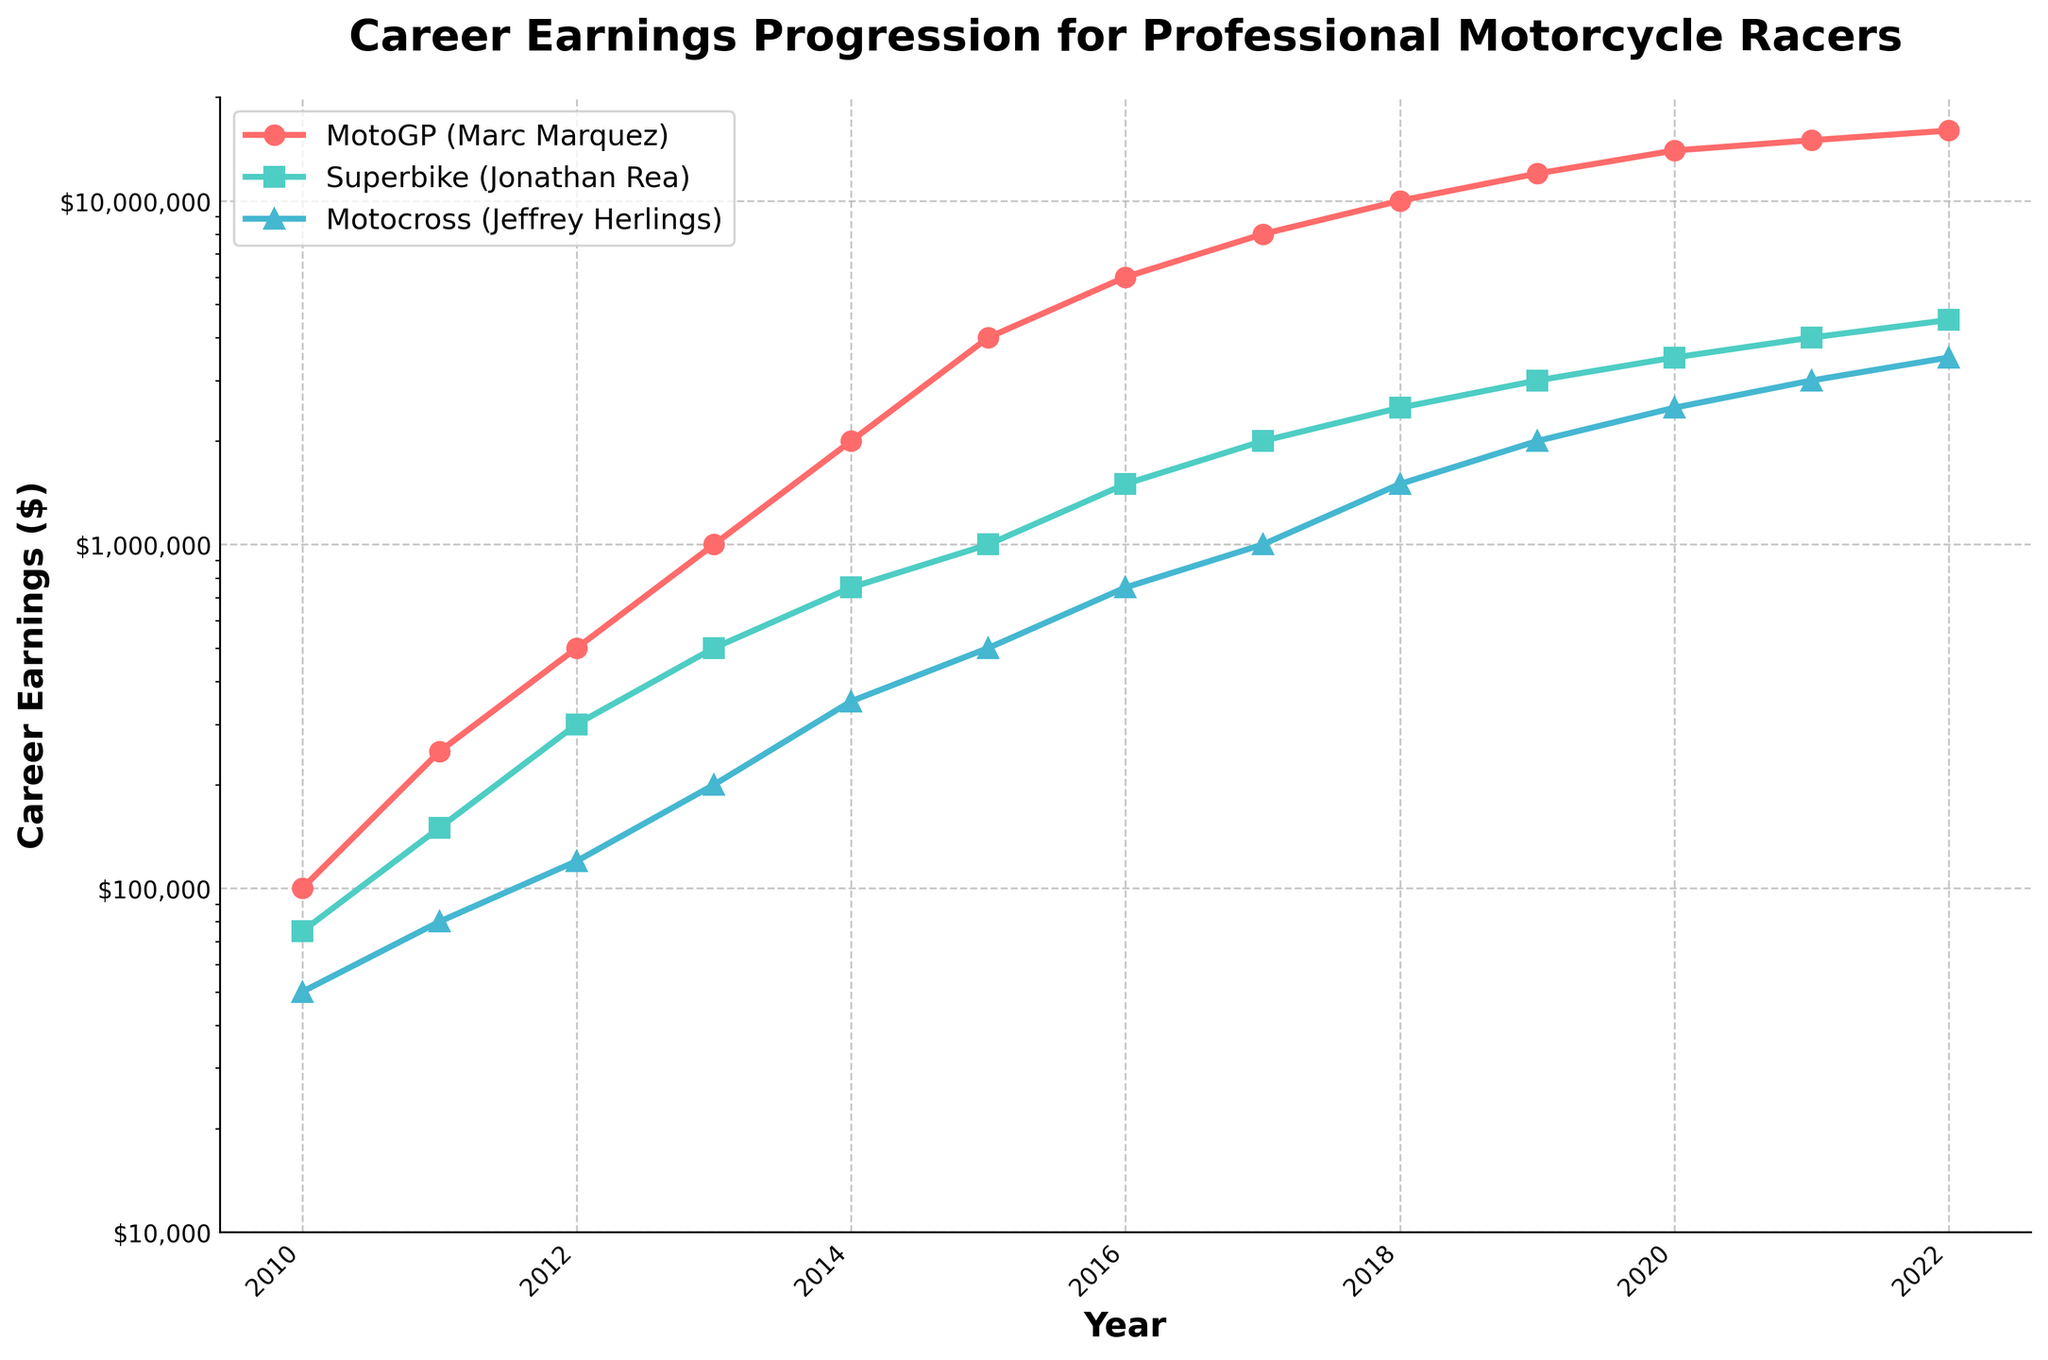How many more earnings did Marc Marquez have in 2022 compared to Jonathan Rea? To determine how much more Marc Marquez earned compared to Jonathan Rea in 2022, subtract Jonathan Rea's earnings from Marc Marquez's earnings: $16,000,000 (Marquez) - $4,500,000 (Rea) = $11,500,000
Answer: $11,500,000 Which rider had the steepest increase in earnings between 2015 and 2016? Examine the increase in earnings for each rider between 2015 and 2016: Marc Marquez's earnings increased from $4,000,000 to $6,000,000 ($2,000,000 increase); Jonathan Rea's earnings increased from $1,000,000 to $1,500,000 ($500,000 increase); Jeffrey Herlings' earnings increased from $500,000 to $750,000 ($250,000 increase). The steepest increase is for Marc Marquez.
Answer: Marc Marquez Was there a year when the earnings for all three riders were below $1,000,000? Review the earnings data year by year to check if all three riders' earnings are below $1,000,000. In 2010, Marc Marquez earned $100,000, Jonathan Rea earned $75,000, and Jeffrey Herlings earned $50,000, all of which are below $1,000,000.
Answer: 2010 In which year did Jeffrey Herlings' earnings first exceed $1,000,000? Examine the yearly earnings for Jeffrey Herlings until finding the first instance when the amount exceeds $1,000,000. This occurs in 2017 when his earnings are $1,000,000 exactly, and in 2018 they reach $1,500,000. So, 2018 is the year his earnings first exceed $1,000,000.
Answer: 2018 How long did it take for Jonathan Rea's earnings to increase from $750,000 to $4,000,000? Identify the years when Jonathan Rea's earnings were $750,000 and $4,000,000. His earnings were $750,000 in 2014 and $4,000,000 in 2021, so it took 2021 - 2014 = 7 years.
Answer: 7 years Which rider had the highest earnings in 2013, and what were they? Compare the earnings of the three riders in 2013: Marc Marquez ($1,000,000), Jonathan Rea ($500,000), Jeffrey Herlings ($200,000). The highest earnings in 2013 were by Marc Marquez with $1,000,000.
Answer: Marc Marquez, $1,000,000 What is the total earnings difference between MotoGP and Superbike from 2010 to 2022? Sum the earnings for Marc Marquez (MotoGP) and Jonathan Rea (Superbike) from 2010 to 2022, then calculate the difference. Total earnings for Marc Marquez: $160,000,000, Jonathan Rea: $45,750,000. Difference: $160,000,000 - $45,750,000 = $114,250,000
Answer: $114,250,000 Which rider showed the lowest year-over-year growth rate in the first five years? Analyze each rider's earnings growth rate from 2010-2015 and identify the lowest year-over-year increase. By calculating and comparing the annual changes in earnings percentage-wise: Jonathan Rea's growth is less aggressive compared to the others.
Answer: Jonathan Rea 